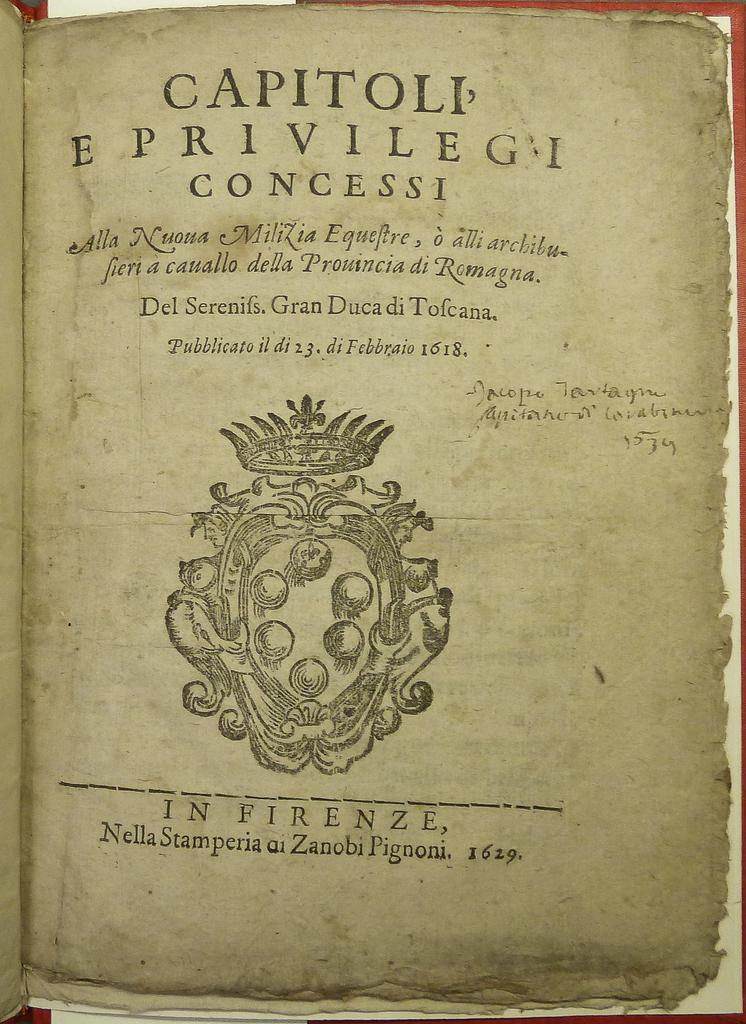Can you describe this image briefly? This is a picture of the paper of a book , where there is a name of the book, logo and some words on the paper. 